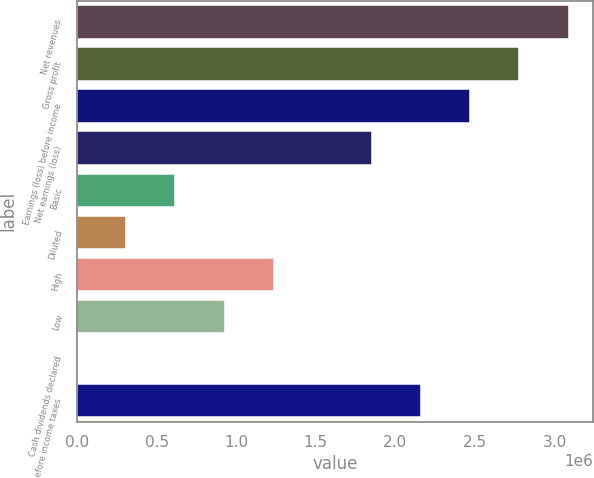<chart> <loc_0><loc_0><loc_500><loc_500><bar_chart><fcel>Net revenues<fcel>Gross profit<fcel>Earnings (loss) before income<fcel>Net earnings (loss)<fcel>Basic<fcel>Diluted<fcel>High<fcel>Low<fcel>Cash dividends declared<fcel>Earnings before income taxes<nl><fcel>3.08763e+06<fcel>2.77886e+06<fcel>2.4701e+06<fcel>1.85258e+06<fcel>617526<fcel>308763<fcel>1.23505e+06<fcel>926288<fcel>0.36<fcel>2.16134e+06<nl></chart> 